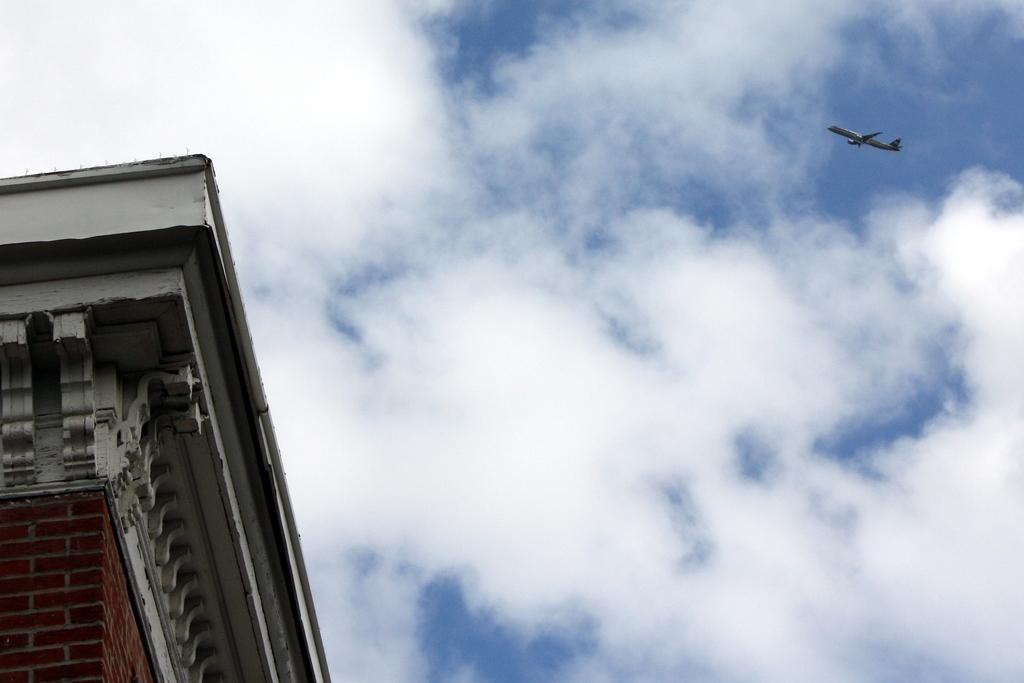What type of structure is present in the image? There is a building in the image. What part of the natural environment is visible in the image? The sky is visible in the image. What is moving in the air in the image? There is a plane moving in the air in the image. What type of creature is holding the yarn in the image? There is no creature holding yarn in the image; it only features a building, the sky, and a moving plane. 